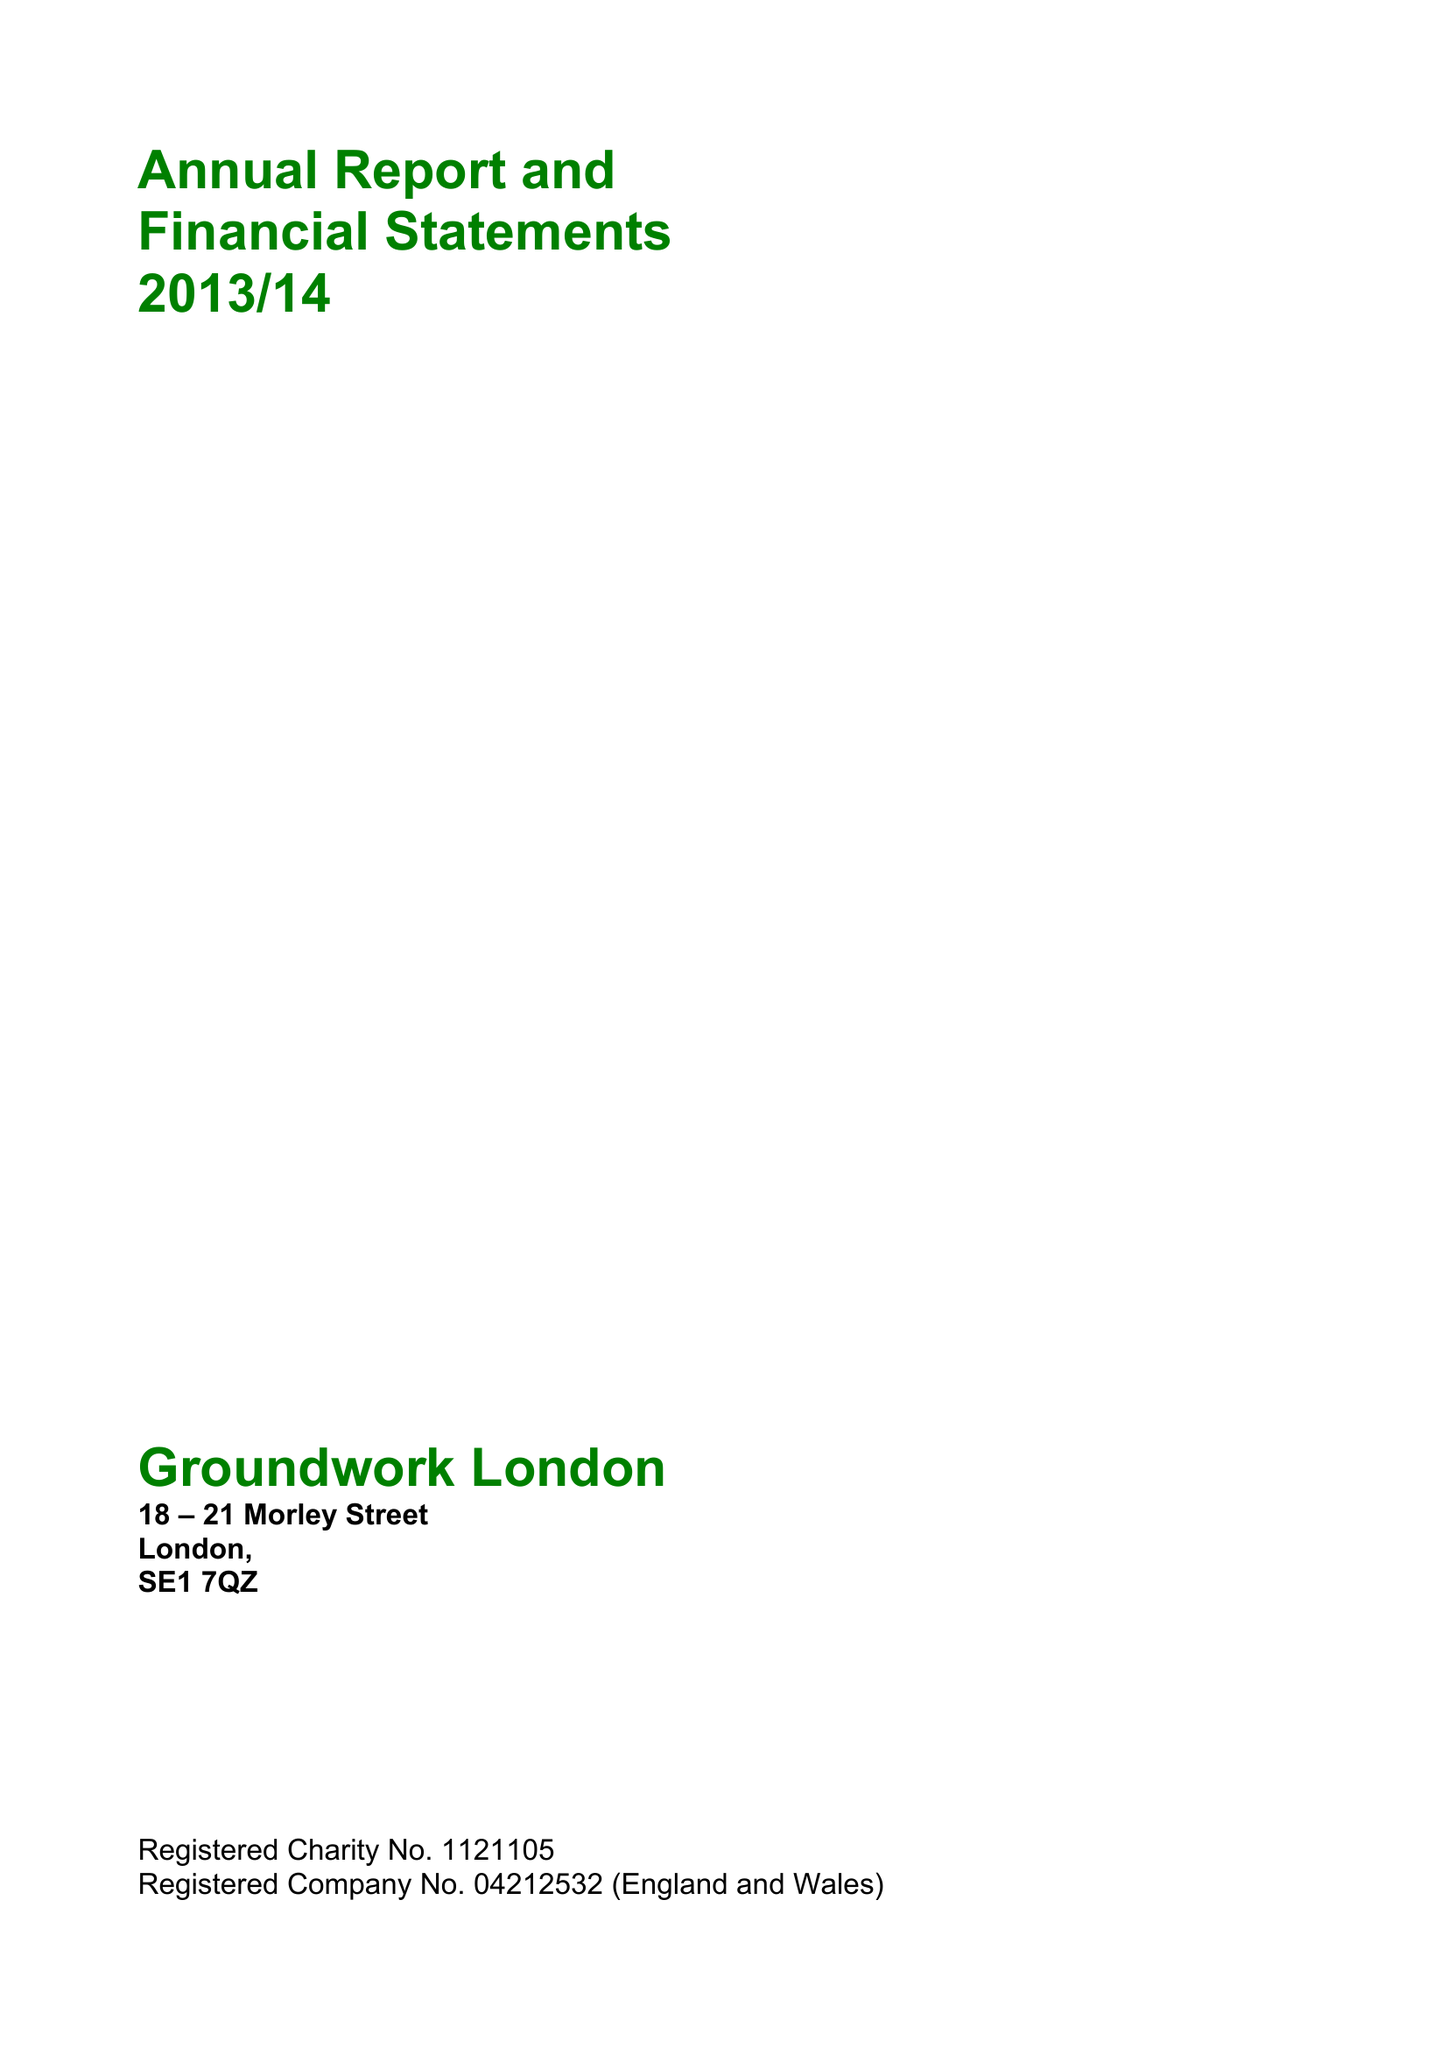What is the value for the address__street_line?
Answer the question using a single word or phrase. 18-21 MORLEY STREET 